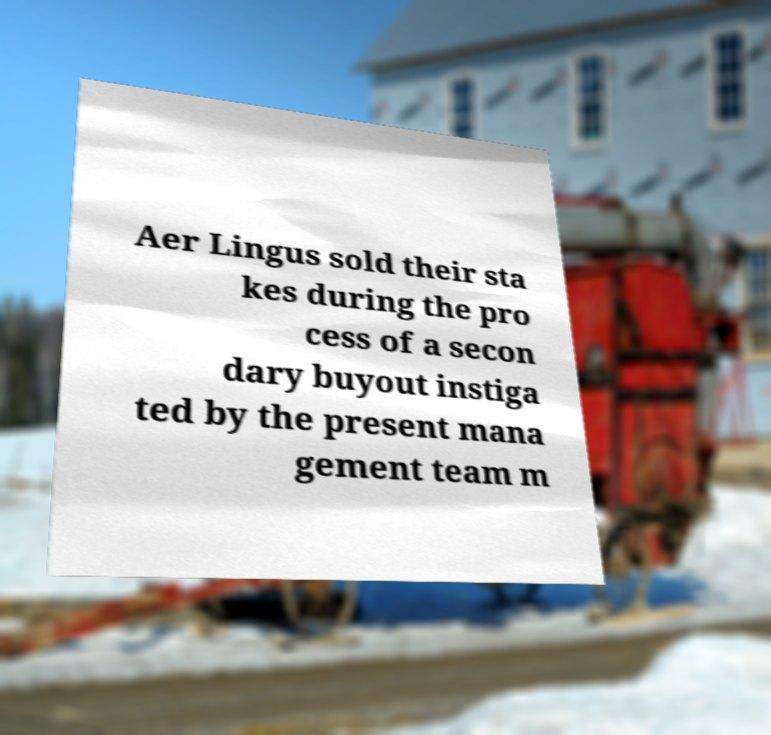What messages or text are displayed in this image? I need them in a readable, typed format. Aer Lingus sold their sta kes during the pro cess of a secon dary buyout instiga ted by the present mana gement team m 